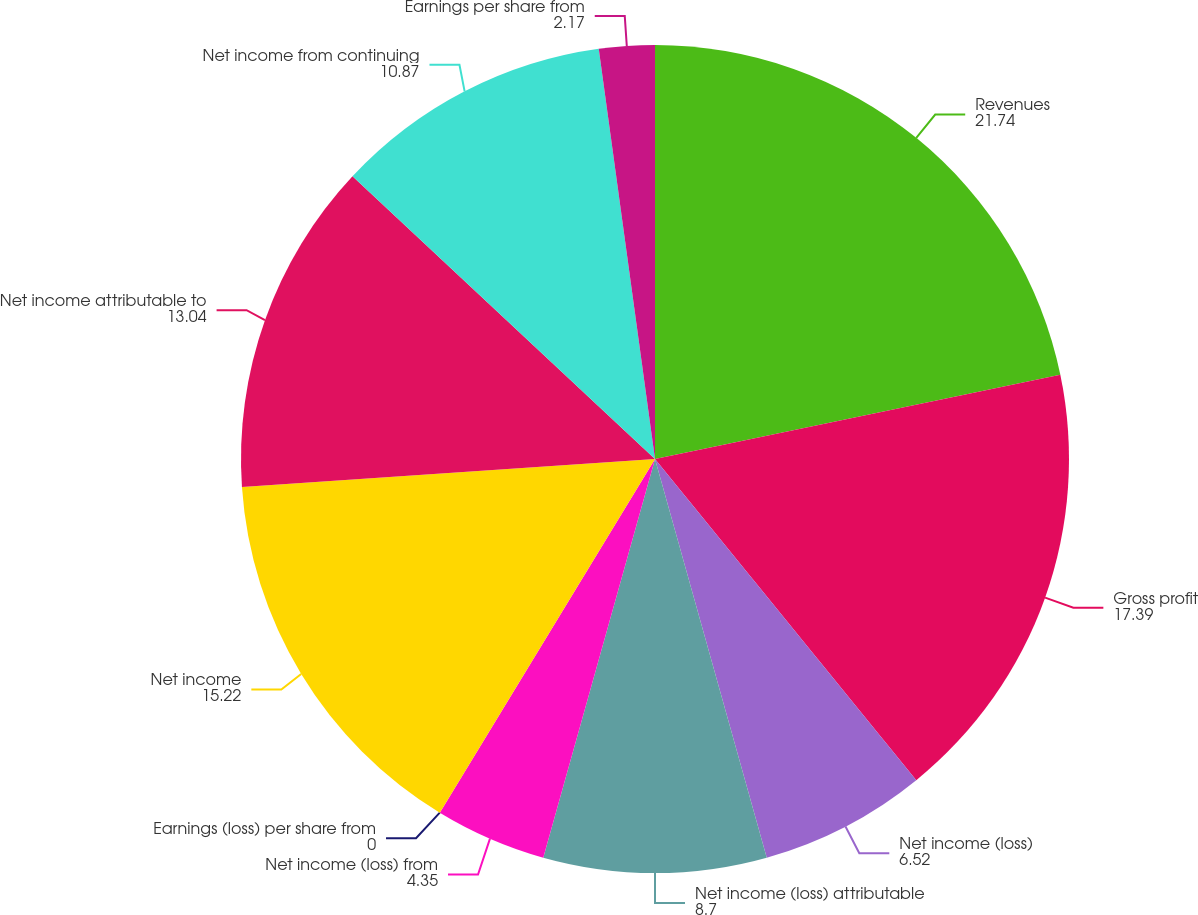Convert chart. <chart><loc_0><loc_0><loc_500><loc_500><pie_chart><fcel>Revenues<fcel>Gross profit<fcel>Net income (loss)<fcel>Net income (loss) attributable<fcel>Net income (loss) from<fcel>Earnings (loss) per share from<fcel>Net income<fcel>Net income attributable to<fcel>Net income from continuing<fcel>Earnings per share from<nl><fcel>21.74%<fcel>17.39%<fcel>6.52%<fcel>8.7%<fcel>4.35%<fcel>0.0%<fcel>15.22%<fcel>13.04%<fcel>10.87%<fcel>2.17%<nl></chart> 